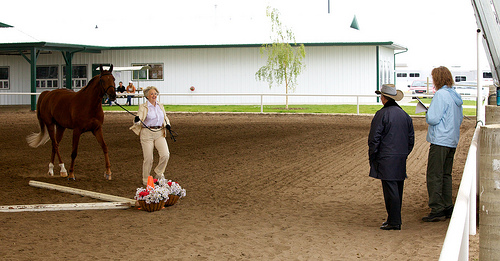<image>
Can you confirm if the tree is to the left of the woman? Yes. From this viewpoint, the tree is positioned to the left side relative to the woman. Where is the horse in relation to the man? Is it in front of the man? Yes. The horse is positioned in front of the man, appearing closer to the camera viewpoint. 